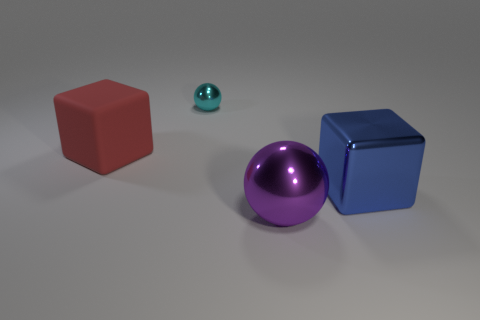Are there the same number of big purple metallic objects that are in front of the purple sphere and large gray rubber things? yes 